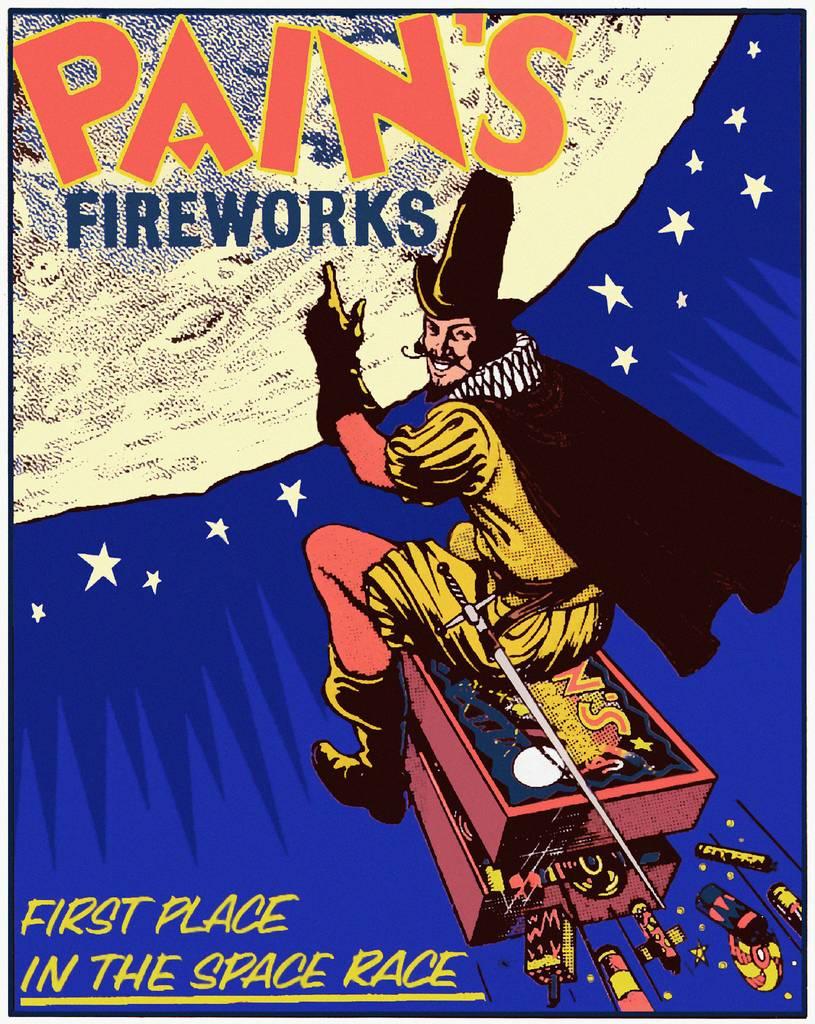First place in the what race?
Your answer should be compact. Space race. 